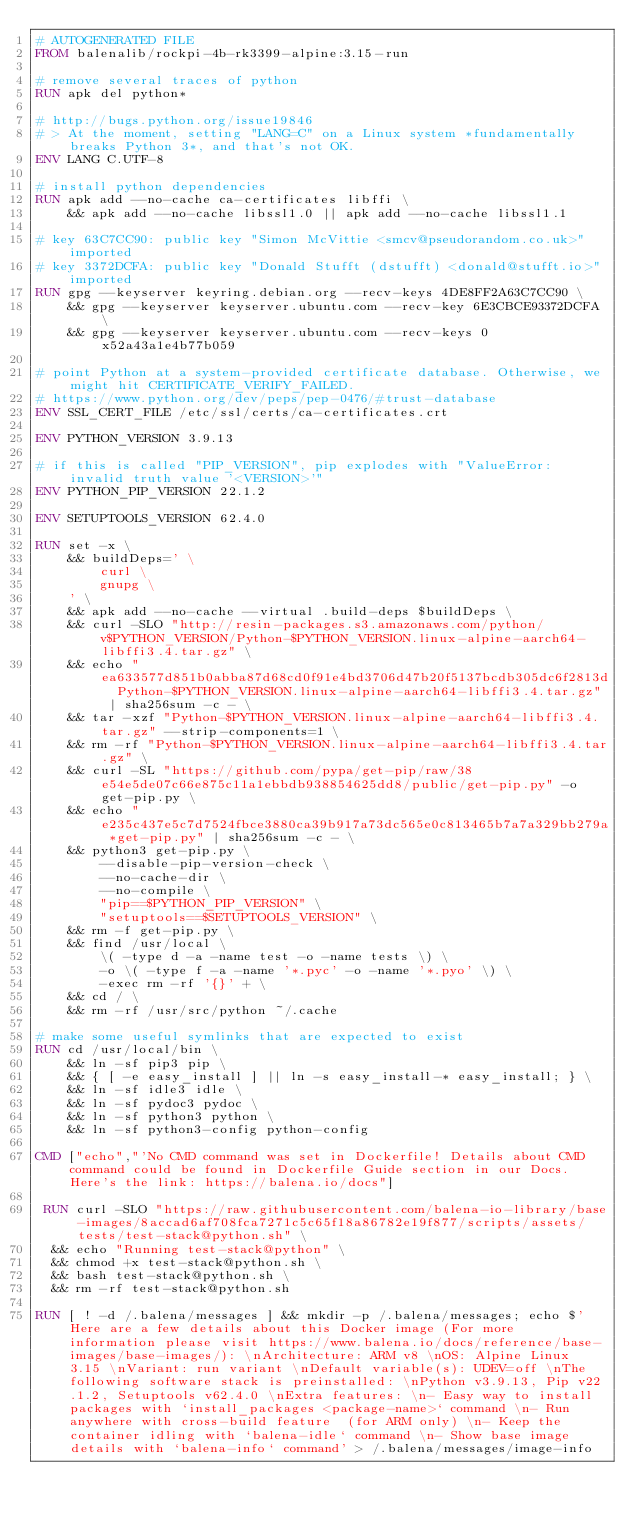<code> <loc_0><loc_0><loc_500><loc_500><_Dockerfile_># AUTOGENERATED FILE
FROM balenalib/rockpi-4b-rk3399-alpine:3.15-run

# remove several traces of python
RUN apk del python*

# http://bugs.python.org/issue19846
# > At the moment, setting "LANG=C" on a Linux system *fundamentally breaks Python 3*, and that's not OK.
ENV LANG C.UTF-8

# install python dependencies
RUN apk add --no-cache ca-certificates libffi \
	&& apk add --no-cache libssl1.0 || apk add --no-cache libssl1.1

# key 63C7CC90: public key "Simon McVittie <smcv@pseudorandom.co.uk>" imported
# key 3372DCFA: public key "Donald Stufft (dstufft) <donald@stufft.io>" imported
RUN gpg --keyserver keyring.debian.org --recv-keys 4DE8FF2A63C7CC90 \
	&& gpg --keyserver keyserver.ubuntu.com --recv-key 6E3CBCE93372DCFA \
	&& gpg --keyserver keyserver.ubuntu.com --recv-keys 0x52a43a1e4b77b059

# point Python at a system-provided certificate database. Otherwise, we might hit CERTIFICATE_VERIFY_FAILED.
# https://www.python.org/dev/peps/pep-0476/#trust-database
ENV SSL_CERT_FILE /etc/ssl/certs/ca-certificates.crt

ENV PYTHON_VERSION 3.9.13

# if this is called "PIP_VERSION", pip explodes with "ValueError: invalid truth value '<VERSION>'"
ENV PYTHON_PIP_VERSION 22.1.2

ENV SETUPTOOLS_VERSION 62.4.0

RUN set -x \
	&& buildDeps=' \
		curl \
		gnupg \
	' \
	&& apk add --no-cache --virtual .build-deps $buildDeps \
	&& curl -SLO "http://resin-packages.s3.amazonaws.com/python/v$PYTHON_VERSION/Python-$PYTHON_VERSION.linux-alpine-aarch64-libffi3.4.tar.gz" \
	&& echo "ea633577d851b0abba87d68cd0f91e4bd3706d47b20f5137bcdb305dc6f2813d  Python-$PYTHON_VERSION.linux-alpine-aarch64-libffi3.4.tar.gz" | sha256sum -c - \
	&& tar -xzf "Python-$PYTHON_VERSION.linux-alpine-aarch64-libffi3.4.tar.gz" --strip-components=1 \
	&& rm -rf "Python-$PYTHON_VERSION.linux-alpine-aarch64-libffi3.4.tar.gz" \
	&& curl -SL "https://github.com/pypa/get-pip/raw/38e54e5de07c66e875c11a1ebbdb938854625dd8/public/get-pip.py" -o get-pip.py \
    && echo "e235c437e5c7d7524fbce3880ca39b917a73dc565e0c813465b7a7a329bb279a *get-pip.py" | sha256sum -c - \
    && python3 get-pip.py \
        --disable-pip-version-check \
        --no-cache-dir \
        --no-compile \
        "pip==$PYTHON_PIP_VERSION" \
        "setuptools==$SETUPTOOLS_VERSION" \
	&& rm -f get-pip.py \
	&& find /usr/local \
		\( -type d -a -name test -o -name tests \) \
		-o \( -type f -a -name '*.pyc' -o -name '*.pyo' \) \
		-exec rm -rf '{}' + \
	&& cd / \
	&& rm -rf /usr/src/python ~/.cache

# make some useful symlinks that are expected to exist
RUN cd /usr/local/bin \
	&& ln -sf pip3 pip \
	&& { [ -e easy_install ] || ln -s easy_install-* easy_install; } \
	&& ln -sf idle3 idle \
	&& ln -sf pydoc3 pydoc \
	&& ln -sf python3 python \
	&& ln -sf python3-config python-config

CMD ["echo","'No CMD command was set in Dockerfile! Details about CMD command could be found in Dockerfile Guide section in our Docs. Here's the link: https://balena.io/docs"]

 RUN curl -SLO "https://raw.githubusercontent.com/balena-io-library/base-images/8accad6af708fca7271c5c65f18a86782e19f877/scripts/assets/tests/test-stack@python.sh" \
  && echo "Running test-stack@python" \
  && chmod +x test-stack@python.sh \
  && bash test-stack@python.sh \
  && rm -rf test-stack@python.sh 

RUN [ ! -d /.balena/messages ] && mkdir -p /.balena/messages; echo $'Here are a few details about this Docker image (For more information please visit https://www.balena.io/docs/reference/base-images/base-images/): \nArchitecture: ARM v8 \nOS: Alpine Linux 3.15 \nVariant: run variant \nDefault variable(s): UDEV=off \nThe following software stack is preinstalled: \nPython v3.9.13, Pip v22.1.2, Setuptools v62.4.0 \nExtra features: \n- Easy way to install packages with `install_packages <package-name>` command \n- Run anywhere with cross-build feature  (for ARM only) \n- Keep the container idling with `balena-idle` command \n- Show base image details with `balena-info` command' > /.balena/messages/image-info</code> 